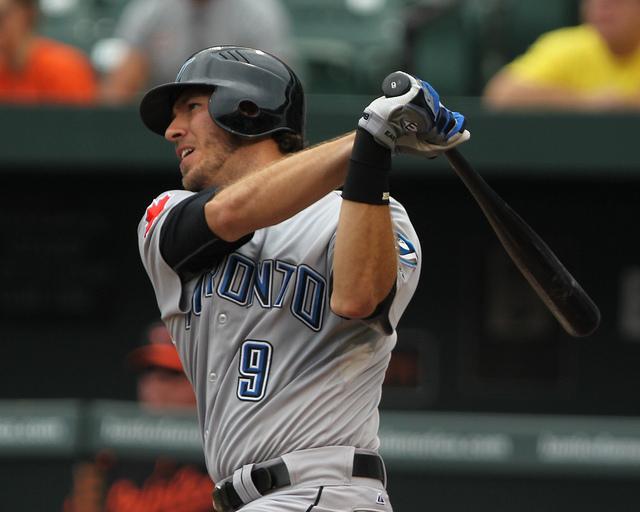What color is the bat?
Be succinct. Black. What team is up to bat?
Quick response, please. Toronto. What is the guy's Jersey number?
Answer briefly. 9. Is this person wearing a belt?
Write a very short answer. Yes. What is the number on the batter's shirt?
Write a very short answer. 9. 